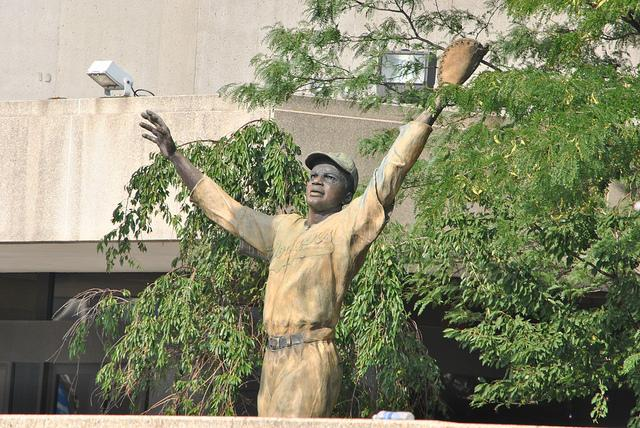What is the statue wearing? baseball uniform 